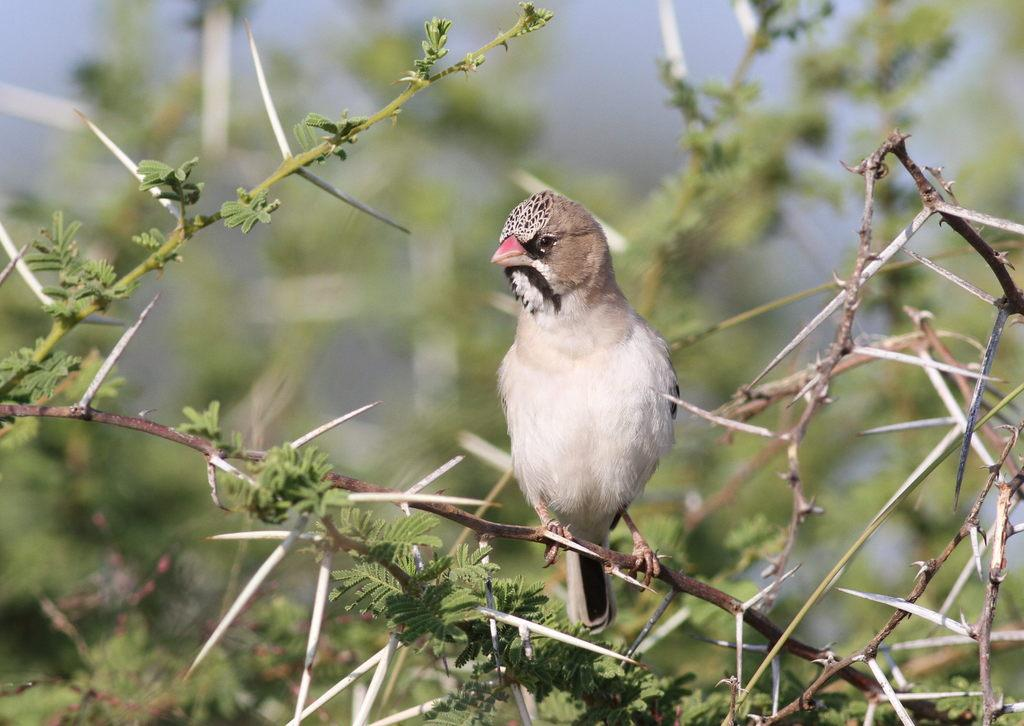What can be seen in the image that has a pointed shape? There are spikes in the image. What type of animal is in the middle of the image? There is a bird in the middle of the image. How would you describe the appearance of the background in the image? The background of the image is blurry. What type of shock can be seen in the image? There is no shock present in the image; it features spikes and a bird. Can you tell me how many robins are in the image? There is only one bird in the image, and it is not specified as a robin. 